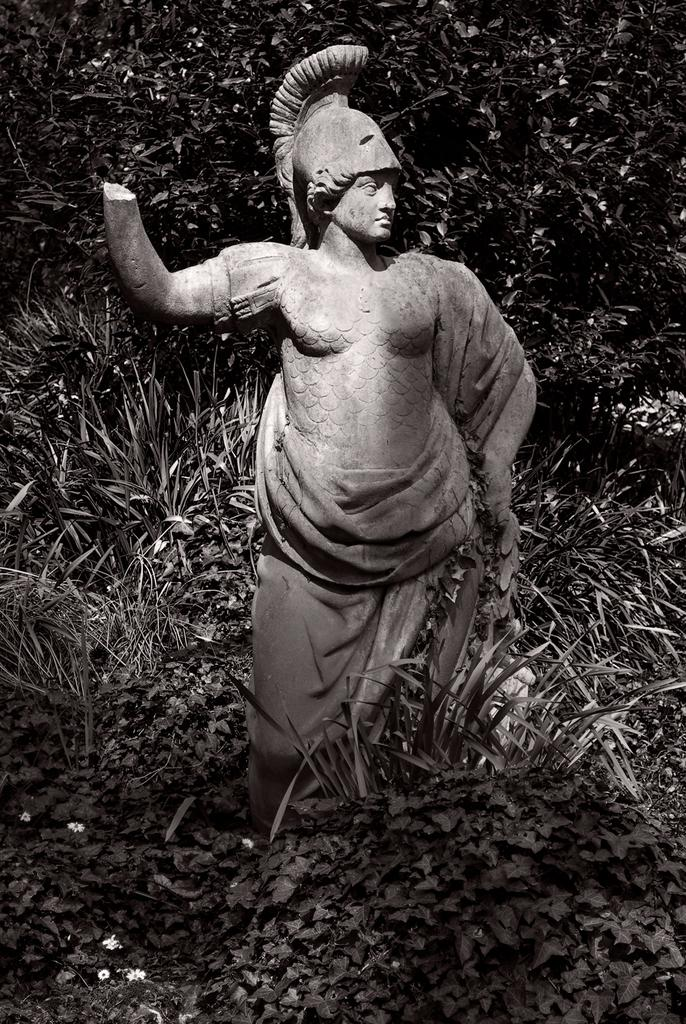What is the main subject in the image? There is a statue in the image. Where is the statue located? The statue is present on the ground. What type of vegetation can be seen in the image? There are plants and trees in the image. What type of scissors are being used to trim the trees in the image? There are no scissors present in the image, and the trees are not being trimmed. 